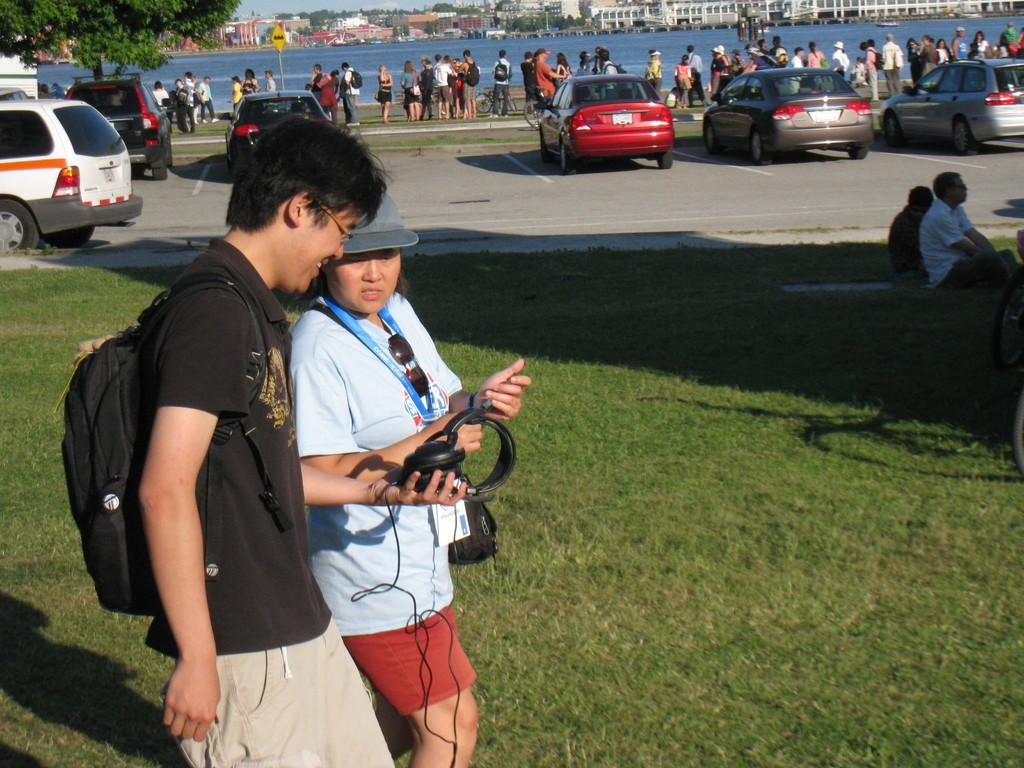Who can be seen in the image? There is a man and a woman in the image. What are they doing in the image? They are walking on the grass. Can you describe the background of the image? In the background, there are persons, vehicles on the road, trees, water, sign boards, buildings, and the sky. What type of polish is being applied to the dock in the image? There is no dock or polish present in the image. In which direction are the man and woman walking in the image? The direction in which the man and woman are walking cannot be determined from the image. 